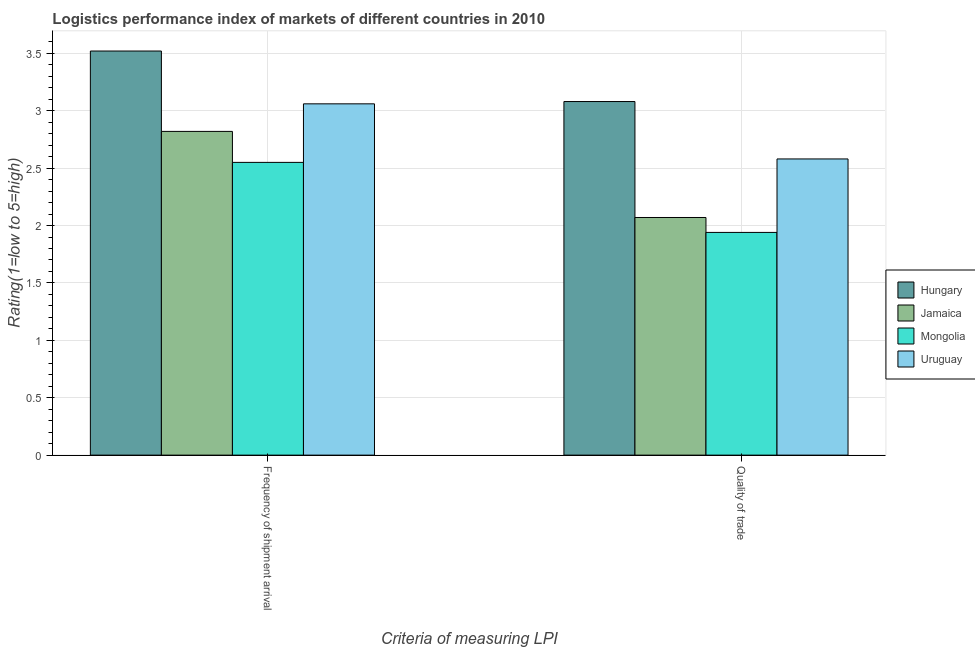How many different coloured bars are there?
Give a very brief answer. 4. How many groups of bars are there?
Make the answer very short. 2. Are the number of bars per tick equal to the number of legend labels?
Give a very brief answer. Yes. How many bars are there on the 2nd tick from the left?
Your response must be concise. 4. How many bars are there on the 2nd tick from the right?
Ensure brevity in your answer.  4. What is the label of the 2nd group of bars from the left?
Give a very brief answer. Quality of trade. What is the lpi of frequency of shipment arrival in Jamaica?
Your answer should be compact. 2.82. Across all countries, what is the maximum lpi quality of trade?
Provide a short and direct response. 3.08. Across all countries, what is the minimum lpi quality of trade?
Make the answer very short. 1.94. In which country was the lpi quality of trade maximum?
Offer a very short reply. Hungary. In which country was the lpi quality of trade minimum?
Give a very brief answer. Mongolia. What is the total lpi of frequency of shipment arrival in the graph?
Make the answer very short. 11.95. What is the difference between the lpi of frequency of shipment arrival in Hungary and that in Jamaica?
Your answer should be compact. 0.7. What is the difference between the lpi quality of trade in Jamaica and the lpi of frequency of shipment arrival in Uruguay?
Your response must be concise. -0.99. What is the average lpi of frequency of shipment arrival per country?
Offer a very short reply. 2.99. What is the difference between the lpi of frequency of shipment arrival and lpi quality of trade in Hungary?
Provide a short and direct response. 0.44. What is the ratio of the lpi of frequency of shipment arrival in Mongolia to that in Jamaica?
Provide a short and direct response. 0.9. Is the lpi quality of trade in Jamaica less than that in Mongolia?
Offer a terse response. No. What does the 4th bar from the left in Frequency of shipment arrival represents?
Your answer should be compact. Uruguay. What does the 3rd bar from the right in Quality of trade represents?
Your response must be concise. Jamaica. How many bars are there?
Provide a succinct answer. 8. Are all the bars in the graph horizontal?
Your answer should be very brief. No. How many countries are there in the graph?
Your response must be concise. 4. Are the values on the major ticks of Y-axis written in scientific E-notation?
Make the answer very short. No. Does the graph contain grids?
Offer a very short reply. Yes. What is the title of the graph?
Your response must be concise. Logistics performance index of markets of different countries in 2010. What is the label or title of the X-axis?
Provide a short and direct response. Criteria of measuring LPI. What is the label or title of the Y-axis?
Keep it short and to the point. Rating(1=low to 5=high). What is the Rating(1=low to 5=high) of Hungary in Frequency of shipment arrival?
Ensure brevity in your answer.  3.52. What is the Rating(1=low to 5=high) in Jamaica in Frequency of shipment arrival?
Keep it short and to the point. 2.82. What is the Rating(1=low to 5=high) in Mongolia in Frequency of shipment arrival?
Ensure brevity in your answer.  2.55. What is the Rating(1=low to 5=high) in Uruguay in Frequency of shipment arrival?
Make the answer very short. 3.06. What is the Rating(1=low to 5=high) of Hungary in Quality of trade?
Give a very brief answer. 3.08. What is the Rating(1=low to 5=high) of Jamaica in Quality of trade?
Offer a terse response. 2.07. What is the Rating(1=low to 5=high) of Mongolia in Quality of trade?
Offer a very short reply. 1.94. What is the Rating(1=low to 5=high) of Uruguay in Quality of trade?
Ensure brevity in your answer.  2.58. Across all Criteria of measuring LPI, what is the maximum Rating(1=low to 5=high) of Hungary?
Provide a succinct answer. 3.52. Across all Criteria of measuring LPI, what is the maximum Rating(1=low to 5=high) of Jamaica?
Your answer should be compact. 2.82. Across all Criteria of measuring LPI, what is the maximum Rating(1=low to 5=high) of Mongolia?
Your response must be concise. 2.55. Across all Criteria of measuring LPI, what is the maximum Rating(1=low to 5=high) in Uruguay?
Your response must be concise. 3.06. Across all Criteria of measuring LPI, what is the minimum Rating(1=low to 5=high) of Hungary?
Your response must be concise. 3.08. Across all Criteria of measuring LPI, what is the minimum Rating(1=low to 5=high) of Jamaica?
Make the answer very short. 2.07. Across all Criteria of measuring LPI, what is the minimum Rating(1=low to 5=high) of Mongolia?
Your response must be concise. 1.94. Across all Criteria of measuring LPI, what is the minimum Rating(1=low to 5=high) in Uruguay?
Offer a very short reply. 2.58. What is the total Rating(1=low to 5=high) of Hungary in the graph?
Ensure brevity in your answer.  6.6. What is the total Rating(1=low to 5=high) of Jamaica in the graph?
Provide a short and direct response. 4.89. What is the total Rating(1=low to 5=high) of Mongolia in the graph?
Offer a terse response. 4.49. What is the total Rating(1=low to 5=high) of Uruguay in the graph?
Give a very brief answer. 5.64. What is the difference between the Rating(1=low to 5=high) of Hungary in Frequency of shipment arrival and that in Quality of trade?
Your response must be concise. 0.44. What is the difference between the Rating(1=low to 5=high) of Jamaica in Frequency of shipment arrival and that in Quality of trade?
Provide a short and direct response. 0.75. What is the difference between the Rating(1=low to 5=high) of Mongolia in Frequency of shipment arrival and that in Quality of trade?
Give a very brief answer. 0.61. What is the difference between the Rating(1=low to 5=high) in Uruguay in Frequency of shipment arrival and that in Quality of trade?
Give a very brief answer. 0.48. What is the difference between the Rating(1=low to 5=high) in Hungary in Frequency of shipment arrival and the Rating(1=low to 5=high) in Jamaica in Quality of trade?
Provide a short and direct response. 1.45. What is the difference between the Rating(1=low to 5=high) of Hungary in Frequency of shipment arrival and the Rating(1=low to 5=high) of Mongolia in Quality of trade?
Your response must be concise. 1.58. What is the difference between the Rating(1=low to 5=high) of Hungary in Frequency of shipment arrival and the Rating(1=low to 5=high) of Uruguay in Quality of trade?
Your response must be concise. 0.94. What is the difference between the Rating(1=low to 5=high) of Jamaica in Frequency of shipment arrival and the Rating(1=low to 5=high) of Mongolia in Quality of trade?
Your response must be concise. 0.88. What is the difference between the Rating(1=low to 5=high) of Jamaica in Frequency of shipment arrival and the Rating(1=low to 5=high) of Uruguay in Quality of trade?
Offer a terse response. 0.24. What is the difference between the Rating(1=low to 5=high) of Mongolia in Frequency of shipment arrival and the Rating(1=low to 5=high) of Uruguay in Quality of trade?
Your answer should be compact. -0.03. What is the average Rating(1=low to 5=high) of Jamaica per Criteria of measuring LPI?
Make the answer very short. 2.44. What is the average Rating(1=low to 5=high) in Mongolia per Criteria of measuring LPI?
Offer a terse response. 2.25. What is the average Rating(1=low to 5=high) in Uruguay per Criteria of measuring LPI?
Your response must be concise. 2.82. What is the difference between the Rating(1=low to 5=high) in Hungary and Rating(1=low to 5=high) in Mongolia in Frequency of shipment arrival?
Your answer should be compact. 0.97. What is the difference between the Rating(1=low to 5=high) of Hungary and Rating(1=low to 5=high) of Uruguay in Frequency of shipment arrival?
Your answer should be compact. 0.46. What is the difference between the Rating(1=low to 5=high) in Jamaica and Rating(1=low to 5=high) in Mongolia in Frequency of shipment arrival?
Offer a very short reply. 0.27. What is the difference between the Rating(1=low to 5=high) in Jamaica and Rating(1=low to 5=high) in Uruguay in Frequency of shipment arrival?
Offer a terse response. -0.24. What is the difference between the Rating(1=low to 5=high) in Mongolia and Rating(1=low to 5=high) in Uruguay in Frequency of shipment arrival?
Your answer should be very brief. -0.51. What is the difference between the Rating(1=low to 5=high) of Hungary and Rating(1=low to 5=high) of Mongolia in Quality of trade?
Your answer should be very brief. 1.14. What is the difference between the Rating(1=low to 5=high) in Jamaica and Rating(1=low to 5=high) in Mongolia in Quality of trade?
Offer a terse response. 0.13. What is the difference between the Rating(1=low to 5=high) of Jamaica and Rating(1=low to 5=high) of Uruguay in Quality of trade?
Provide a short and direct response. -0.51. What is the difference between the Rating(1=low to 5=high) of Mongolia and Rating(1=low to 5=high) of Uruguay in Quality of trade?
Your answer should be compact. -0.64. What is the ratio of the Rating(1=low to 5=high) in Jamaica in Frequency of shipment arrival to that in Quality of trade?
Your answer should be very brief. 1.36. What is the ratio of the Rating(1=low to 5=high) in Mongolia in Frequency of shipment arrival to that in Quality of trade?
Your response must be concise. 1.31. What is the ratio of the Rating(1=low to 5=high) in Uruguay in Frequency of shipment arrival to that in Quality of trade?
Offer a very short reply. 1.19. What is the difference between the highest and the second highest Rating(1=low to 5=high) of Hungary?
Keep it short and to the point. 0.44. What is the difference between the highest and the second highest Rating(1=low to 5=high) of Jamaica?
Make the answer very short. 0.75. What is the difference between the highest and the second highest Rating(1=low to 5=high) in Mongolia?
Provide a short and direct response. 0.61. What is the difference between the highest and the second highest Rating(1=low to 5=high) of Uruguay?
Your answer should be compact. 0.48. What is the difference between the highest and the lowest Rating(1=low to 5=high) in Hungary?
Make the answer very short. 0.44. What is the difference between the highest and the lowest Rating(1=low to 5=high) in Jamaica?
Provide a short and direct response. 0.75. What is the difference between the highest and the lowest Rating(1=low to 5=high) of Mongolia?
Offer a very short reply. 0.61. What is the difference between the highest and the lowest Rating(1=low to 5=high) of Uruguay?
Offer a terse response. 0.48. 